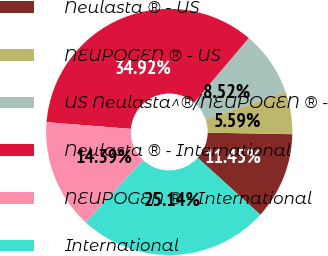Convert chart. <chart><loc_0><loc_0><loc_500><loc_500><pie_chart><fcel>Neulasta ® - US<fcel>NEUPOGEN ® - US<fcel>US Neulasta^®/NEUPOGEN ® -<fcel>Neulasta ® - International<fcel>NEUPOGEN ® - International<fcel>International<nl><fcel>11.45%<fcel>5.59%<fcel>8.52%<fcel>34.92%<fcel>14.39%<fcel>25.14%<nl></chart> 